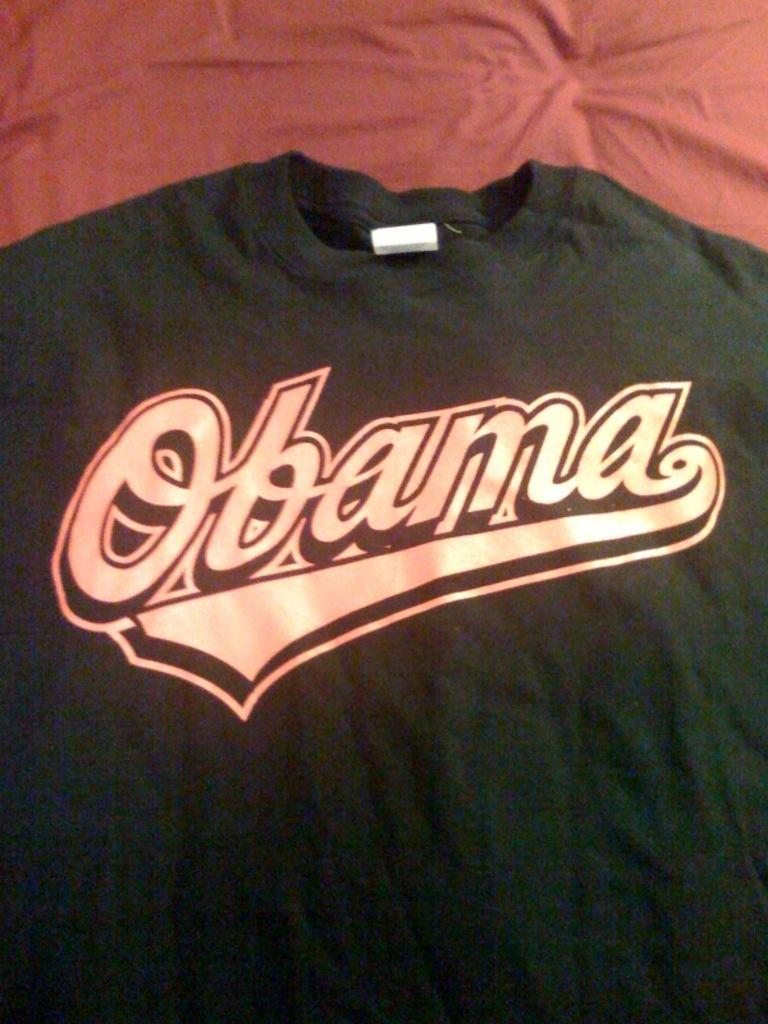What type of clothing item is visible in the image? There is a black t-shirt in the image. What design or feature is present on the t-shirt? The t-shirt has a logo on it. What letter is written on the receipt in the image? There is no receipt present in the image, so it is not possible to determine what letter might be written on it. 